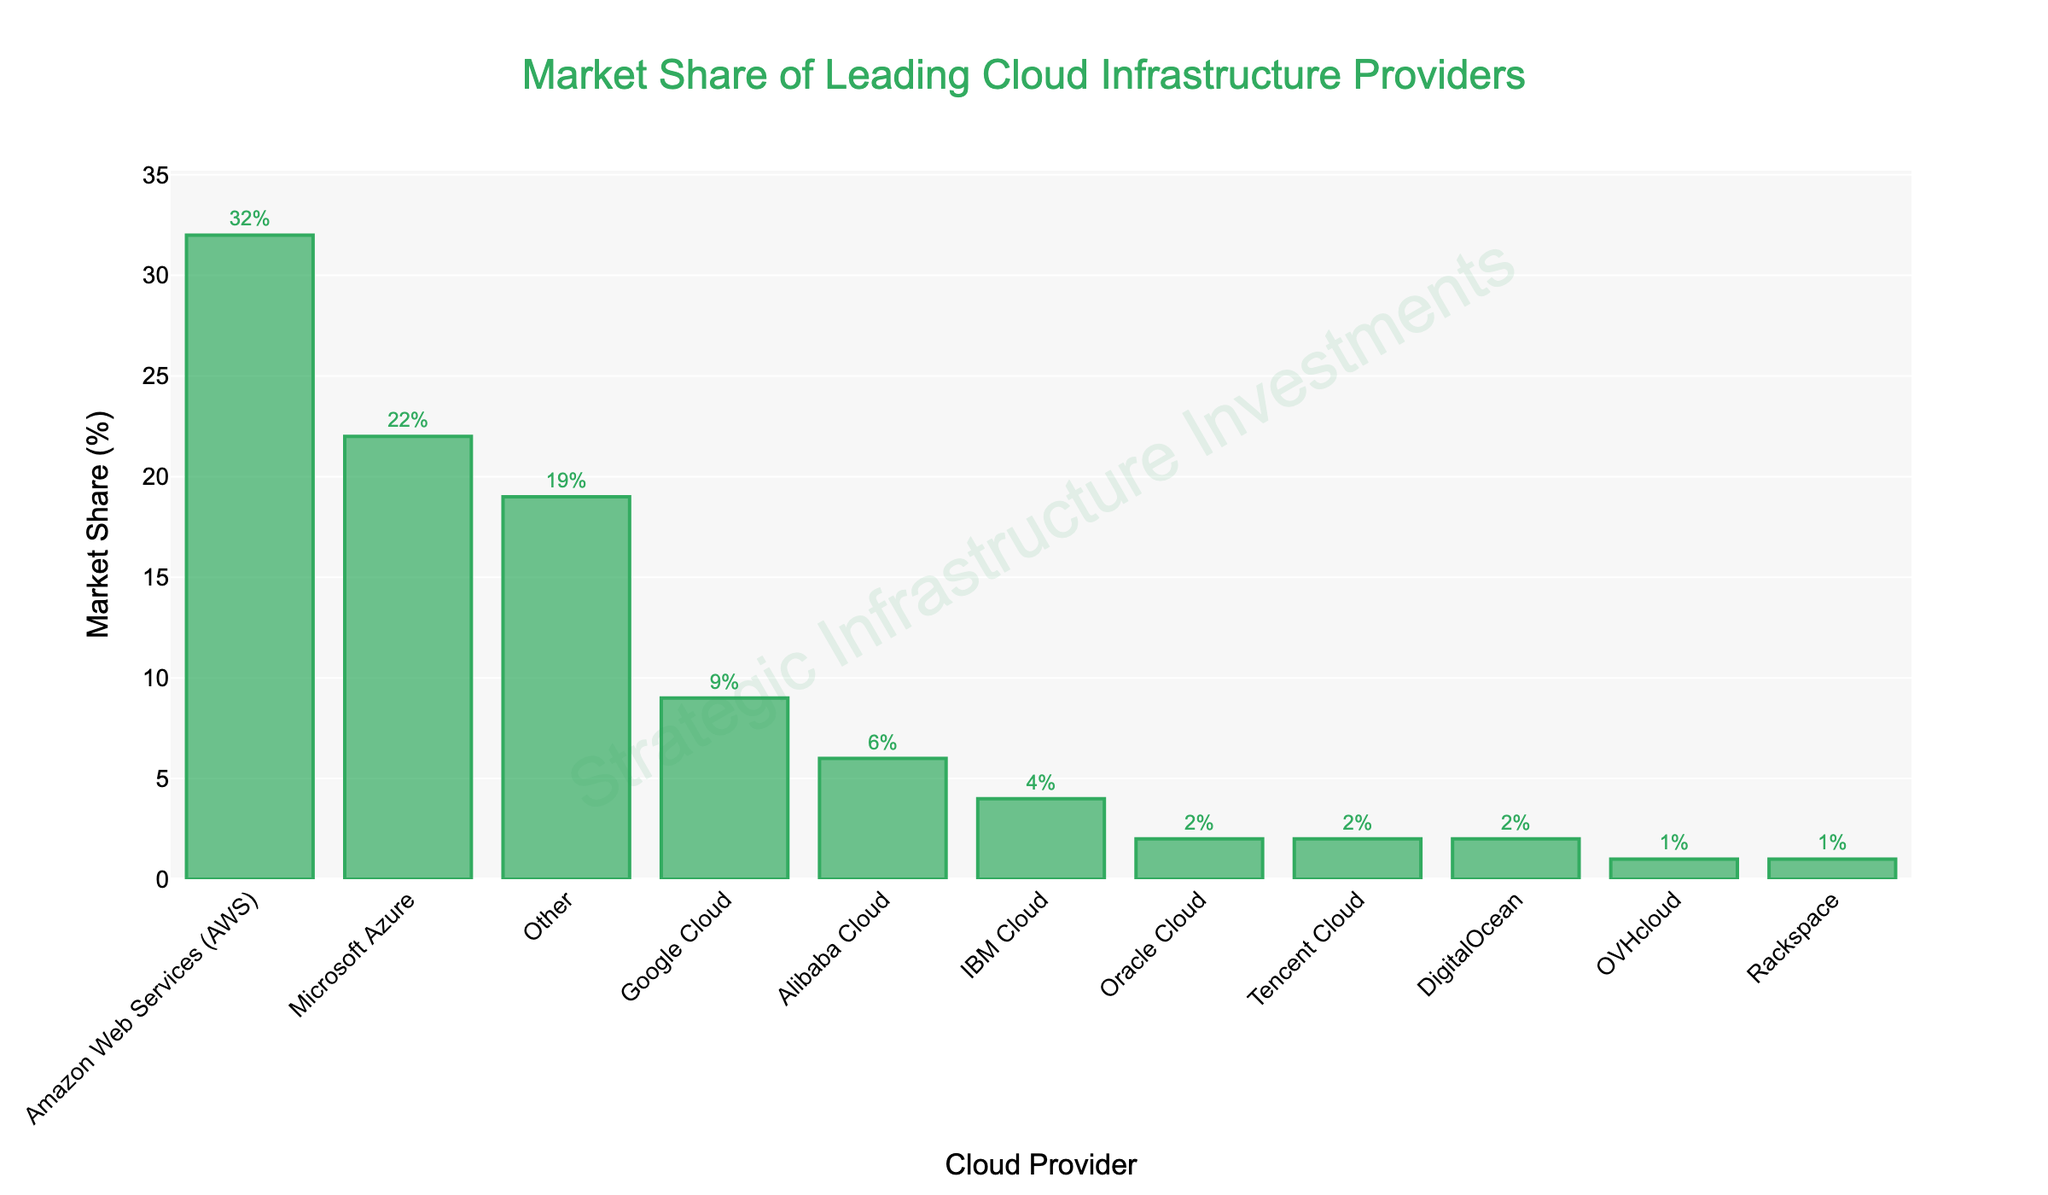What's the market share difference between Amazon Web Services (AWS) and Microsoft Azure? AWS has a market share of 32%, and Microsoft Azure has a market share of 22%. The difference is calculated by subtracting Azure's market share from AWS's market share: 32% - 22% = 10%.
Answer: 10% Which cloud provider has the smallest market share, and what is it? By examining the height of the bars, Rackspace and OVHcloud have the smallest bars. The value indicated next to both of them is 1%.
Answer: OVHcloud and Rackspace, 1% What is the combined market share of Google Cloud, IBM Cloud, and Oracle Cloud? The market shares for Google Cloud, IBM Cloud, and Oracle Cloud are 9%, 4%, and 2%, respectively. Adding these together: 9% + 4% + 2% = 15%.
Answer: 15% Does any single provider have a market share greater than the combined total of Alibaba Cloud, IBM Cloud, and Oracle Cloud? The combined market share of Alibaba Cloud (6%), IBM Cloud (4%), and Oracle Cloud (2%) is 6% + 4% + 2% = 12%. AWS has a market share of 32%, which is greater than 12%.
Answer: Yes, AWS How many providers have a market share of 2%? The providers with a 2% market share are Oracle Cloud, Tencent Cloud, and DigitalOcean. They total three providers.
Answer: 3 What proportion of the market is captured by the 'Other' category? By checking the bar for 'Other', it shows a market share of 19%.
Answer: 19% Which cloud provider is ranked third by market share? The third-largest market share is represented by the third highest bar, which is Google Cloud with 9%.
Answer: Google Cloud How much more market share does Microsoft Azure have compared to Google Cloud? Microsoft Azure has a market share of 22%, whereas Google Cloud has a market share of 9%. The difference is 22% - 9% = 13%.
Answer: 13% What is the total market share of the providers with less than 5%? The providers with less than 5% market share are IBM Cloud (4%), Oracle Cloud (2%), Tencent Cloud (2%), DigitalOcean (2%), OVHcloud (1%), and Rackspace (1%). Adding these: 4% + 2% + 2% + 2% + 1% + 1% = 12%.
Answer: 12% Which cloud providers have a market share within 1% from each other? Oracle Cloud, Tencent Cloud, and DigitalOcean all have a market share of 2%, which means they all have a 0% difference within 1%. OVHcloud and Rackspace both have 1%, making them 0% difference within 1%.
Answer: Oracle Cloud, Tencent Cloud, DigitalOcean; OVHcloud, Rackspace 